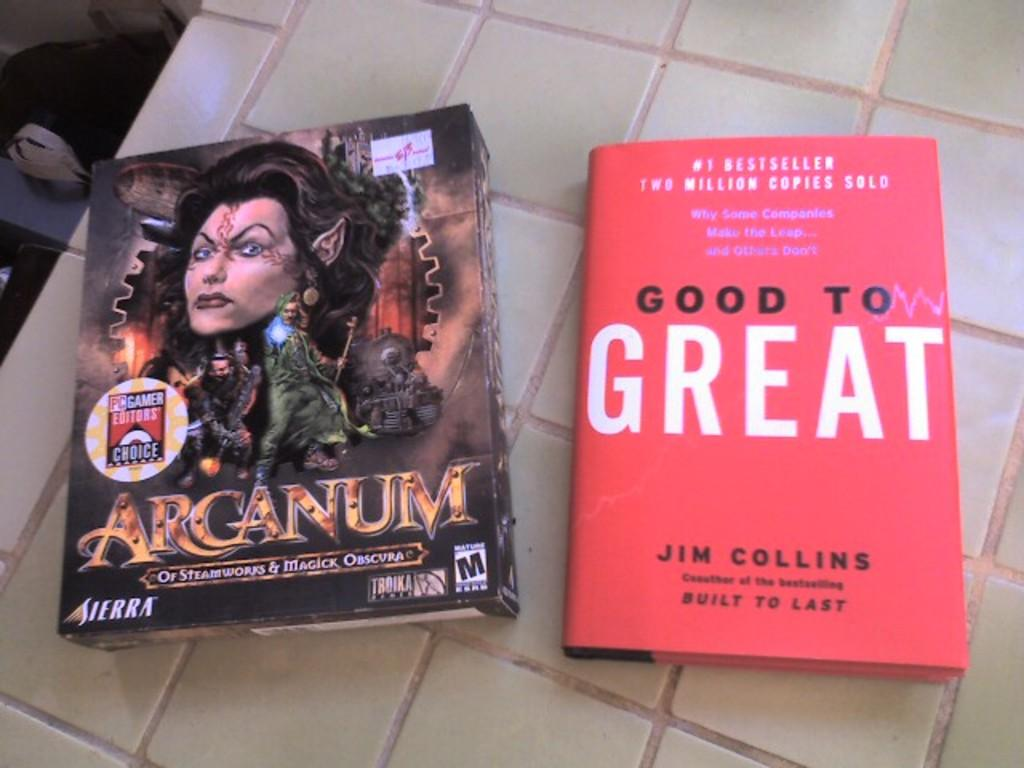<image>
Present a compact description of the photo's key features. A video game, Arcanum, and a book Good to Great sit on a table. 